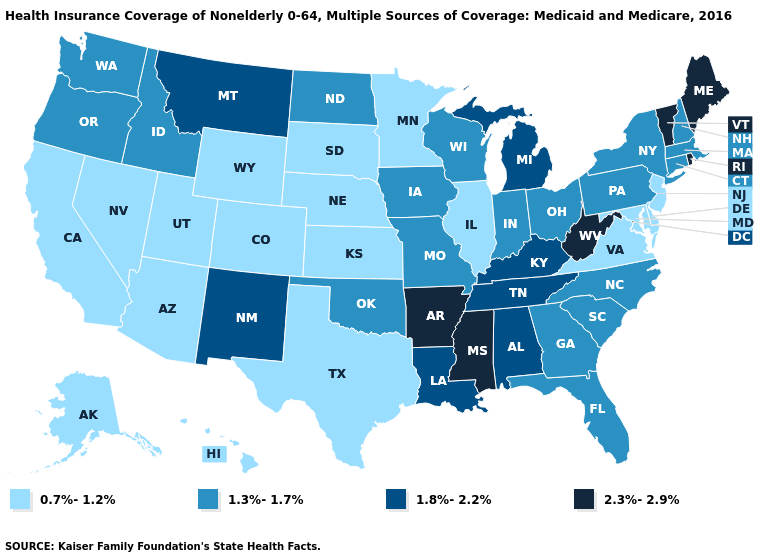Name the states that have a value in the range 0.7%-1.2%?
Write a very short answer. Alaska, Arizona, California, Colorado, Delaware, Hawaii, Illinois, Kansas, Maryland, Minnesota, Nebraska, Nevada, New Jersey, South Dakota, Texas, Utah, Virginia, Wyoming. Name the states that have a value in the range 1.3%-1.7%?
Be succinct. Connecticut, Florida, Georgia, Idaho, Indiana, Iowa, Massachusetts, Missouri, New Hampshire, New York, North Carolina, North Dakota, Ohio, Oklahoma, Oregon, Pennsylvania, South Carolina, Washington, Wisconsin. What is the value of Pennsylvania?
Write a very short answer. 1.3%-1.7%. Name the states that have a value in the range 2.3%-2.9%?
Answer briefly. Arkansas, Maine, Mississippi, Rhode Island, Vermont, West Virginia. What is the lowest value in the USA?
Answer briefly. 0.7%-1.2%. What is the highest value in the South ?
Quick response, please. 2.3%-2.9%. Among the states that border Arizona , does New Mexico have the lowest value?
Give a very brief answer. No. How many symbols are there in the legend?
Be succinct. 4. What is the value of Kentucky?
Keep it brief. 1.8%-2.2%. What is the highest value in the South ?
Concise answer only. 2.3%-2.9%. Does the map have missing data?
Write a very short answer. No. Which states have the lowest value in the USA?
Be succinct. Alaska, Arizona, California, Colorado, Delaware, Hawaii, Illinois, Kansas, Maryland, Minnesota, Nebraska, Nevada, New Jersey, South Dakota, Texas, Utah, Virginia, Wyoming. Does the map have missing data?
Give a very brief answer. No. What is the lowest value in the USA?
Keep it brief. 0.7%-1.2%. Among the states that border Wyoming , does Montana have the lowest value?
Concise answer only. No. 